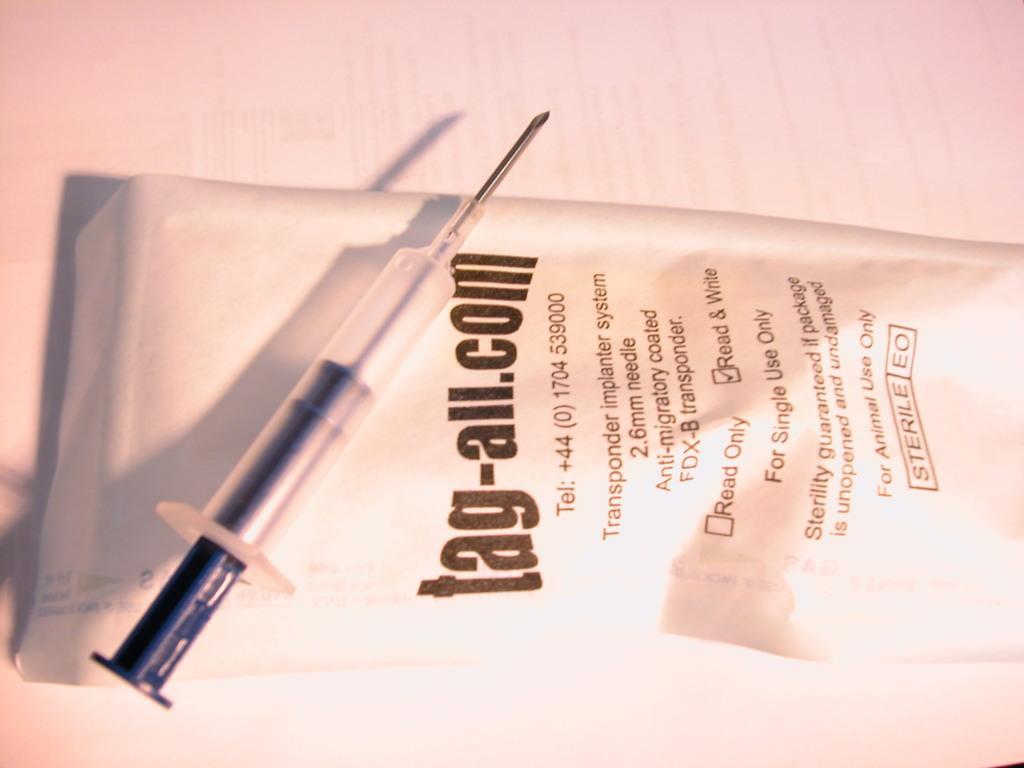Could you give a brief overview of what you see in this image? In the image we can see an injection and a paper. 